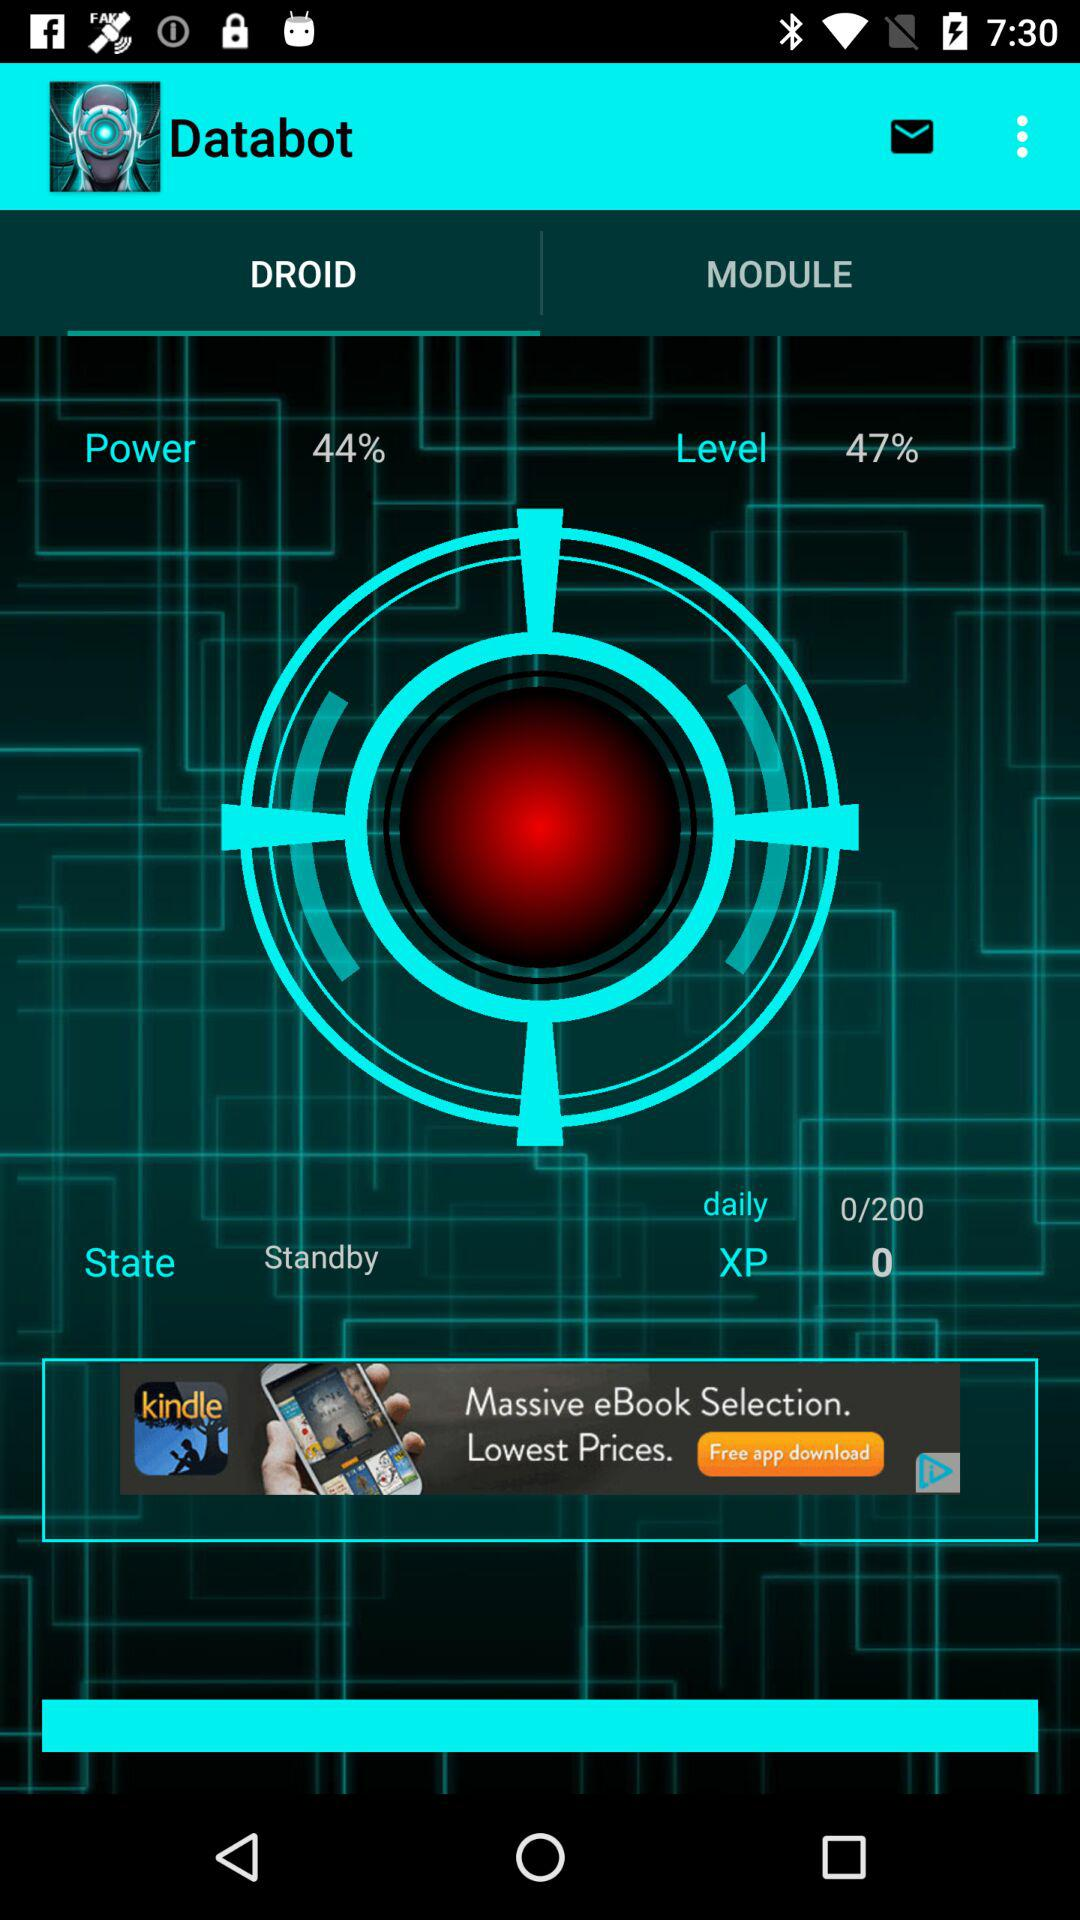How much XP do I need to reach the next level?
Answer the question using a single word or phrase. 200 